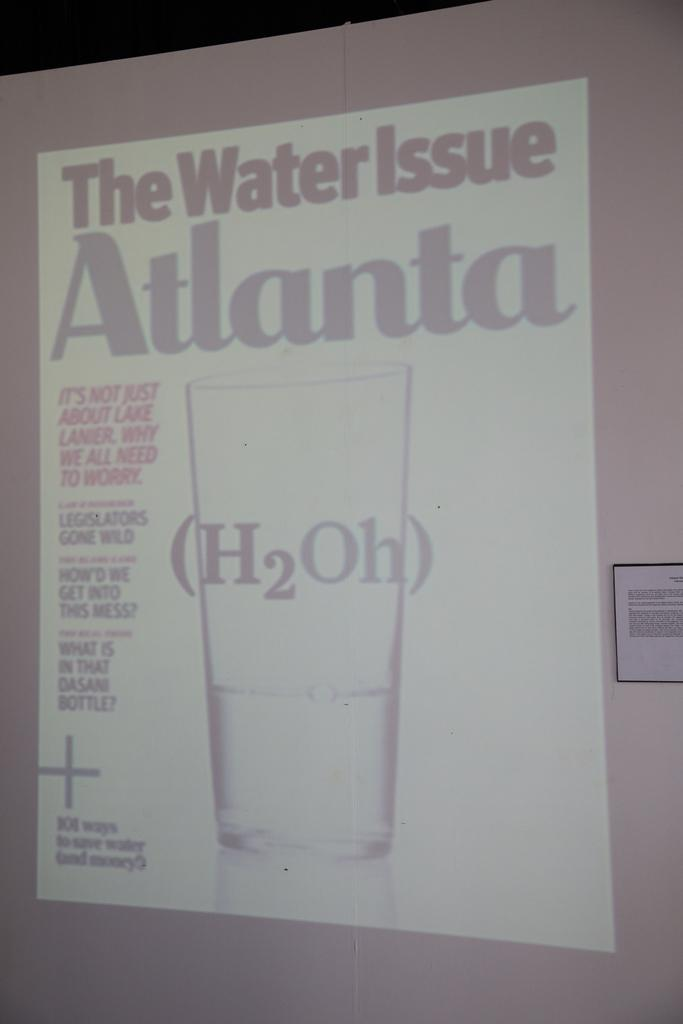What is the main object in the image? There is a projector screen in the image. What is displayed on the projector screen? The projector screen displays a glass of water. Is there any text or writing on the screen? Yes, there is text or writing on the screen. What else can be seen beside the projector screen? There is a board beside the projector screen. How many rays of sunshine can be seen on the chessboard in the image? There is no chessboard present in the image, and therefore no rays of sunshine can be observed on it. What is the level of wealth depicted on the projector screen? The projector screen displays a glass of water, and there is no indication of wealth in the image. 